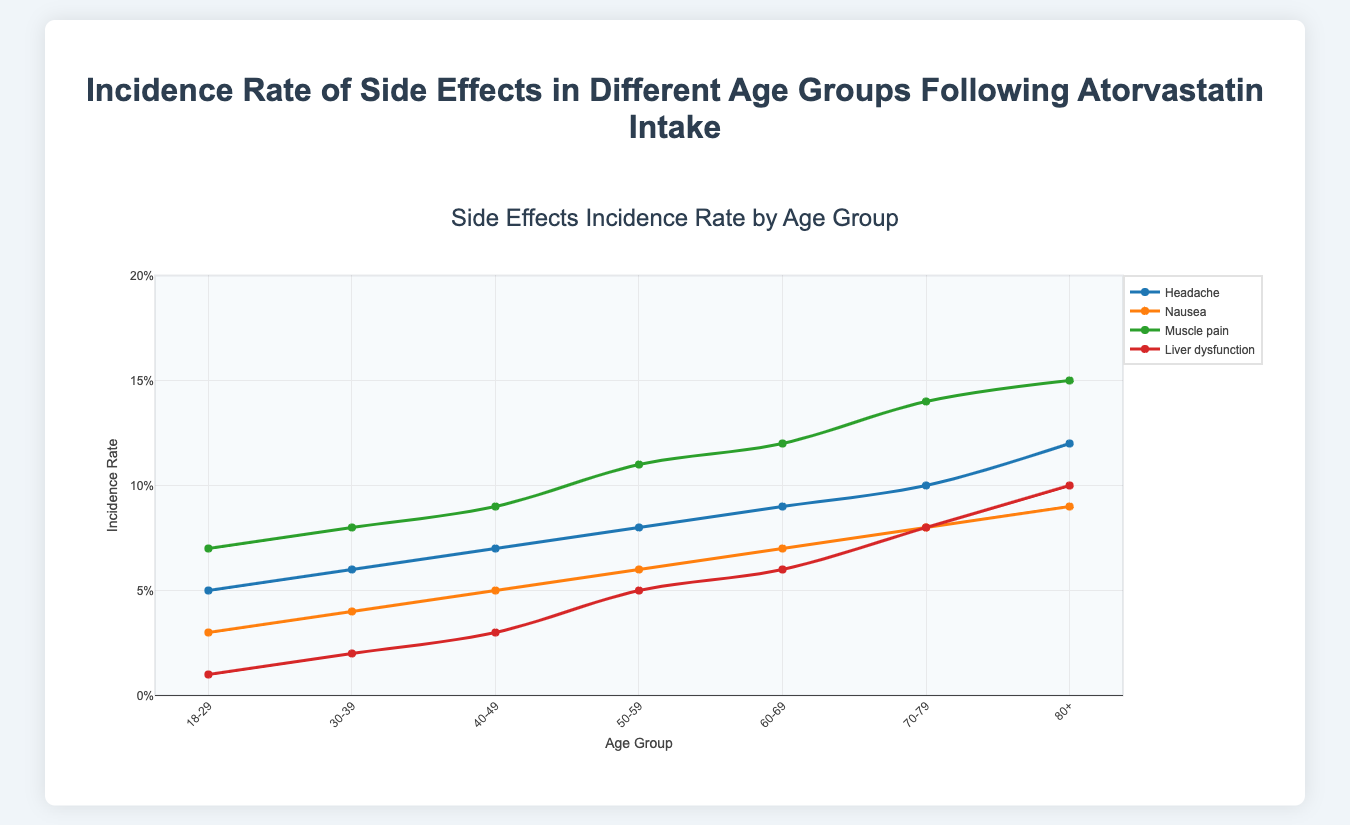What is the incidence rate of headaches for the 70-79 age group? The plot shows the incidence rates for different side effects across age groups. Look for the point where the line representing "Headache" intersects the 70-79 age group on the x-axis.
Answer: 0.10 Which side effect has the highest incidence rate in the 80+ age group? In the 80+ age group, find the lines for each side effect and identify the one with the highest value on the y-axis.
Answer: Muscle pain Compare the incidence rates of liver dysfunction between the 40-49 and 50-59 age groups. Locate the points on the "Liver Dysfunction" line for both age groups and compare their y-values.
Answer: The 50-59 age group has a higher incidence rate (0.05 vs 0.03) What is the average incidence rate of headaches from 30-39 to 60-69 age groups? Sum the incidence rates of headaches for the age groups 30-39, 40-49, 50-59, and 60-69, then divide by 4. (0.06+0.07+0.08+0.09)/4= 0.075
Answer: 0.075 How does the incidence rate of muscle pain change from the 18-29 age group to the 80+ age group? Observe the slope of the "Muscle Pain" line from 18-29 to 80+. It shows an increasing trend, marking the rise in incidence.
Answer: It increases Identify the age group with the lowest incidence rate of nausea. Look for the lowest point on the "Nausea" line.
Answer: 18-29 Between the 50-59 and 60-69 age groups, which group has a higher incidence rate of nausea, and by how much? Determine the incidence rates for nausea in both age groups and subtract the lower incidence rate from the higher one. (0.07 - 0.06)
Answer: 60-69, by 0.01 What is the difference in incidence rates of liver dysfunction between the youngest and oldest age group? Subtract the incidence rate of liver dysfunction in the 18-29 group from that in the 80+ group. (0.10 - 0.01)
Answer: 0.09 